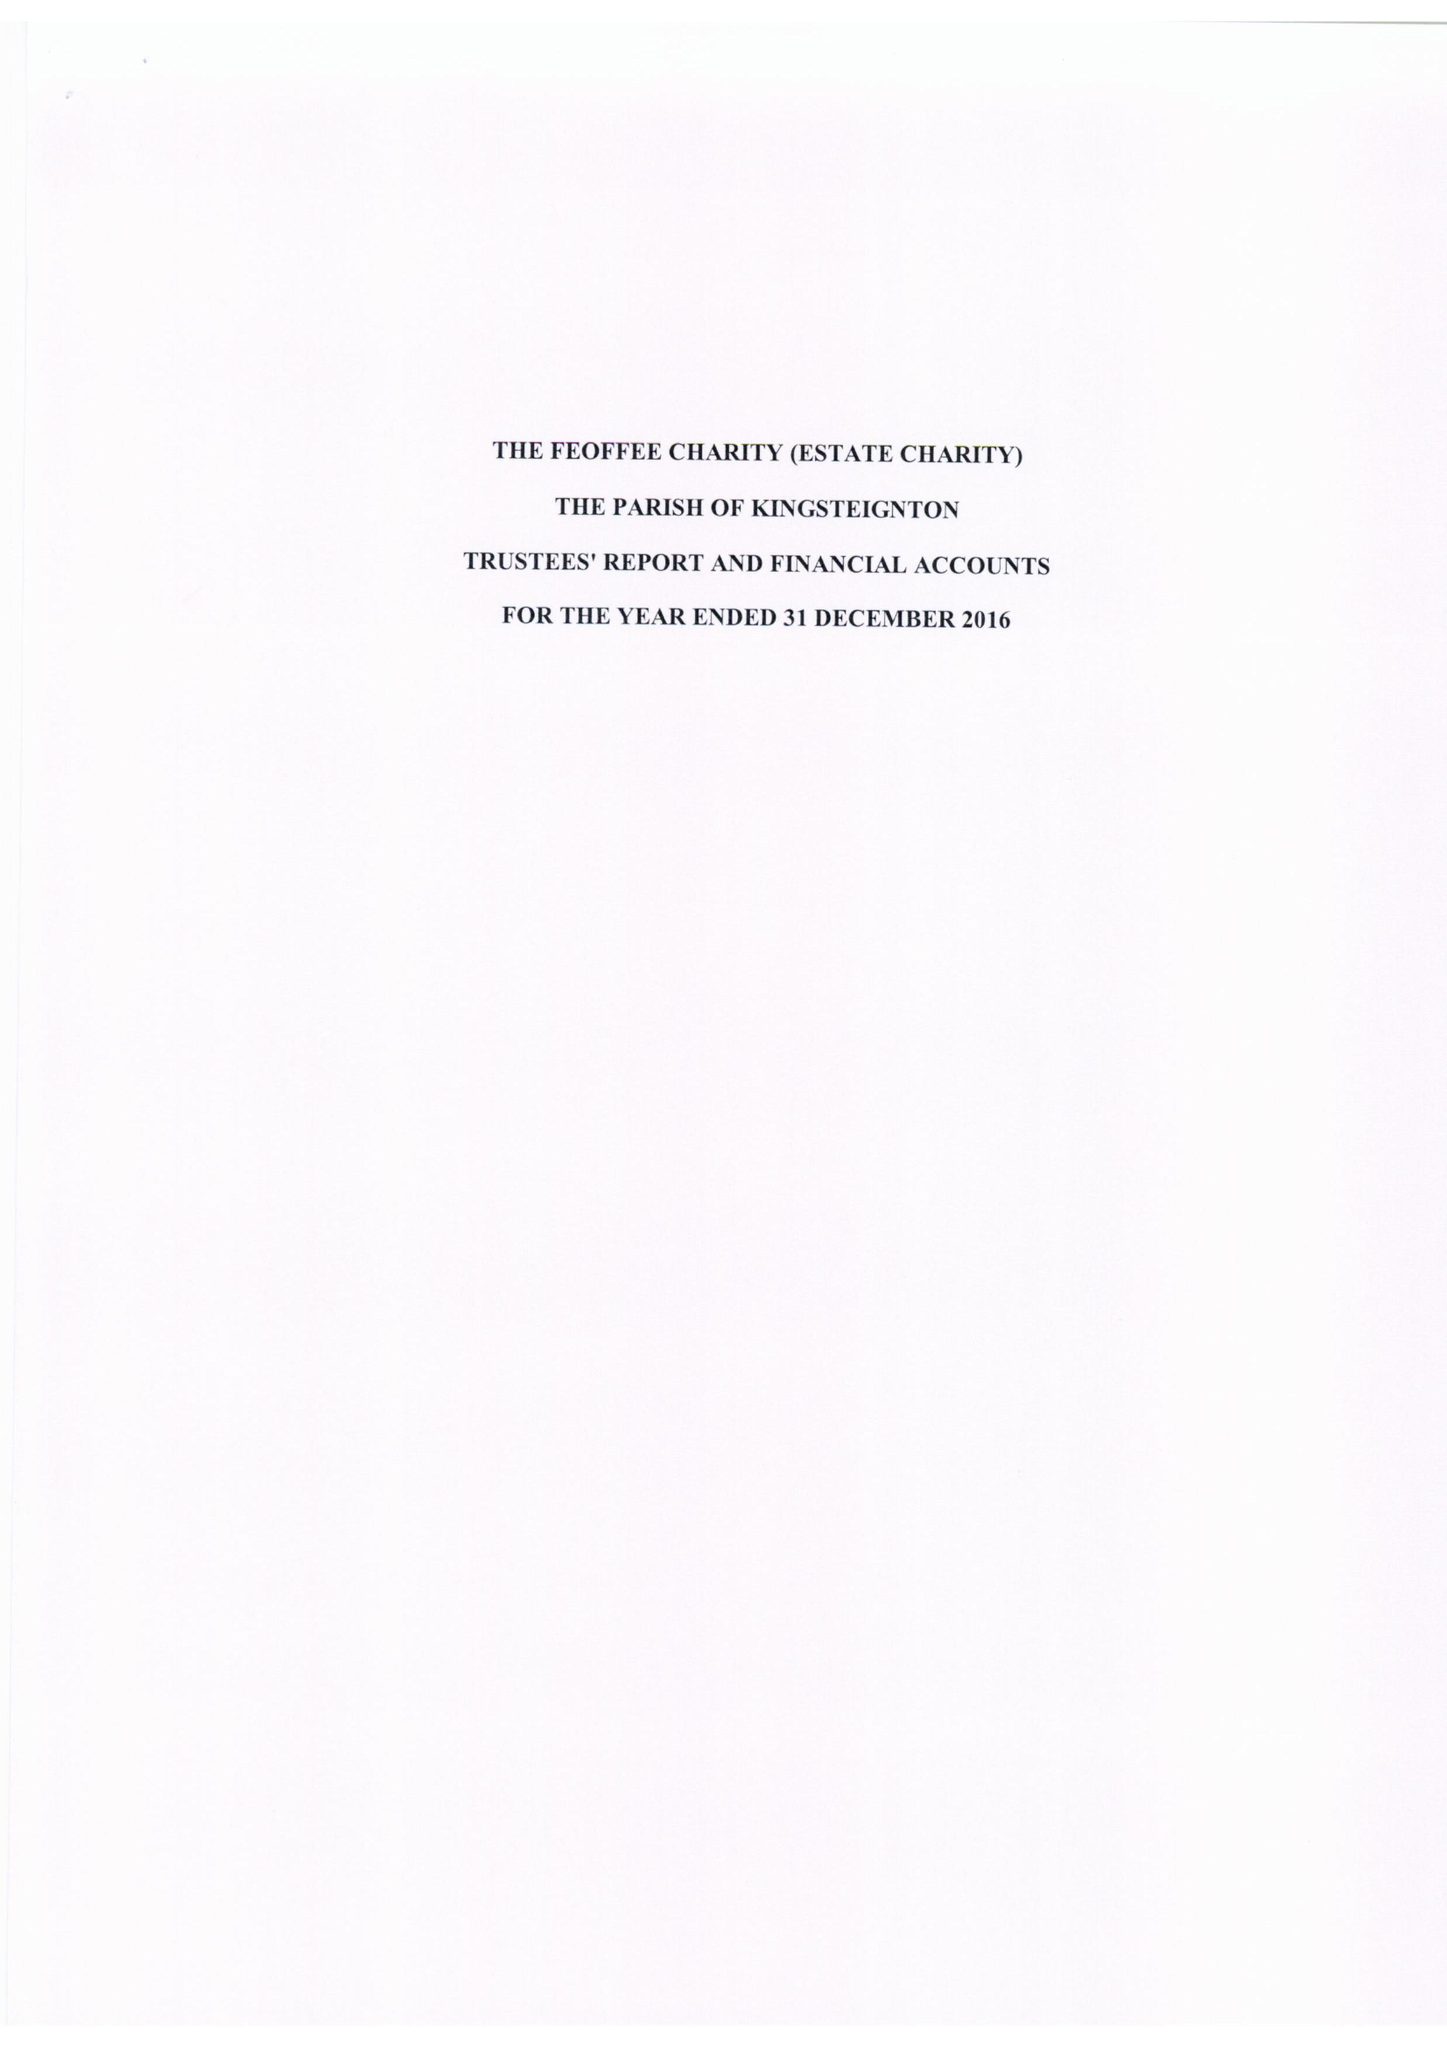What is the value for the income_annually_in_british_pounds?
Answer the question using a single word or phrase. 26647.00 